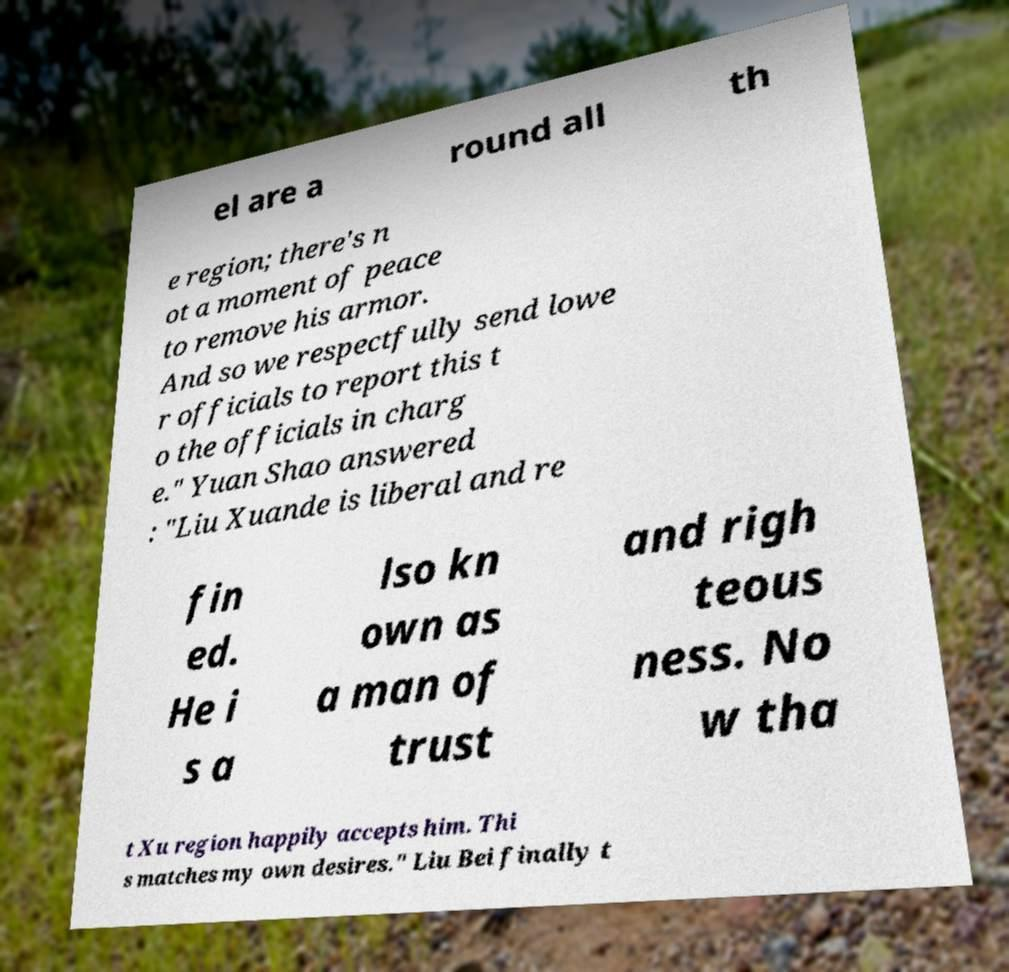There's text embedded in this image that I need extracted. Can you transcribe it verbatim? el are a round all th e region; there's n ot a moment of peace to remove his armor. And so we respectfully send lowe r officials to report this t o the officials in charg e." Yuan Shao answered : "Liu Xuande is liberal and re fin ed. He i s a lso kn own as a man of trust and righ teous ness. No w tha t Xu region happily accepts him. Thi s matches my own desires." Liu Bei finally t 